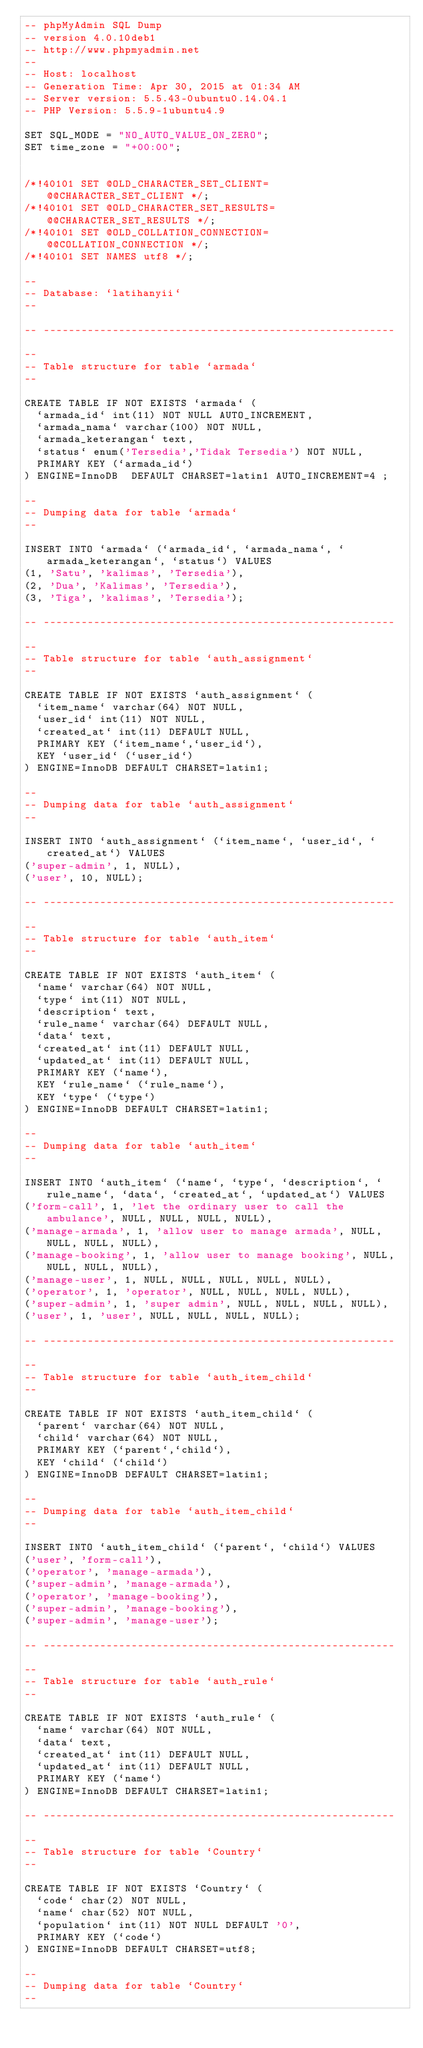<code> <loc_0><loc_0><loc_500><loc_500><_SQL_>-- phpMyAdmin SQL Dump
-- version 4.0.10deb1
-- http://www.phpmyadmin.net
--
-- Host: localhost
-- Generation Time: Apr 30, 2015 at 01:34 AM
-- Server version: 5.5.43-0ubuntu0.14.04.1
-- PHP Version: 5.5.9-1ubuntu4.9

SET SQL_MODE = "NO_AUTO_VALUE_ON_ZERO";
SET time_zone = "+00:00";


/*!40101 SET @OLD_CHARACTER_SET_CLIENT=@@CHARACTER_SET_CLIENT */;
/*!40101 SET @OLD_CHARACTER_SET_RESULTS=@@CHARACTER_SET_RESULTS */;
/*!40101 SET @OLD_COLLATION_CONNECTION=@@COLLATION_CONNECTION */;
/*!40101 SET NAMES utf8 */;

--
-- Database: `latihanyii`
--

-- --------------------------------------------------------

--
-- Table structure for table `armada`
--

CREATE TABLE IF NOT EXISTS `armada` (
  `armada_id` int(11) NOT NULL AUTO_INCREMENT,
  `armada_nama` varchar(100) NOT NULL,
  `armada_keterangan` text,
  `status` enum('Tersedia','Tidak Tersedia') NOT NULL,
  PRIMARY KEY (`armada_id`)
) ENGINE=InnoDB  DEFAULT CHARSET=latin1 AUTO_INCREMENT=4 ;

--
-- Dumping data for table `armada`
--

INSERT INTO `armada` (`armada_id`, `armada_nama`, `armada_keterangan`, `status`) VALUES
(1, 'Satu', 'kalimas', 'Tersedia'),
(2, 'Dua', 'Kalimas', 'Tersedia'),
(3, 'Tiga', 'kalimas', 'Tersedia');

-- --------------------------------------------------------

--
-- Table structure for table `auth_assignment`
--

CREATE TABLE IF NOT EXISTS `auth_assignment` (
  `item_name` varchar(64) NOT NULL,
  `user_id` int(11) NOT NULL,
  `created_at` int(11) DEFAULT NULL,
  PRIMARY KEY (`item_name`,`user_id`),
  KEY `user_id` (`user_id`)
) ENGINE=InnoDB DEFAULT CHARSET=latin1;

--
-- Dumping data for table `auth_assignment`
--

INSERT INTO `auth_assignment` (`item_name`, `user_id`, `created_at`) VALUES
('super-admin', 1, NULL),
('user', 10, NULL);

-- --------------------------------------------------------

--
-- Table structure for table `auth_item`
--

CREATE TABLE IF NOT EXISTS `auth_item` (
  `name` varchar(64) NOT NULL,
  `type` int(11) NOT NULL,
  `description` text,
  `rule_name` varchar(64) DEFAULT NULL,
  `data` text,
  `created_at` int(11) DEFAULT NULL,
  `updated_at` int(11) DEFAULT NULL,
  PRIMARY KEY (`name`),
  KEY `rule_name` (`rule_name`),
  KEY `type` (`type`)
) ENGINE=InnoDB DEFAULT CHARSET=latin1;

--
-- Dumping data for table `auth_item`
--

INSERT INTO `auth_item` (`name`, `type`, `description`, `rule_name`, `data`, `created_at`, `updated_at`) VALUES
('form-call', 1, 'let the ordinary user to call the ambulance', NULL, NULL, NULL, NULL),
('manage-armada', 1, 'allow user to manage armada', NULL, NULL, NULL, NULL),
('manage-booking', 1, 'allow user to manage booking', NULL, NULL, NULL, NULL),
('manage-user', 1, NULL, NULL, NULL, NULL, NULL),
('operator', 1, 'operator', NULL, NULL, NULL, NULL),
('super-admin', 1, 'super admin', NULL, NULL, NULL, NULL),
('user', 1, 'user', NULL, NULL, NULL, NULL);

-- --------------------------------------------------------

--
-- Table structure for table `auth_item_child`
--

CREATE TABLE IF NOT EXISTS `auth_item_child` (
  `parent` varchar(64) NOT NULL,
  `child` varchar(64) NOT NULL,
  PRIMARY KEY (`parent`,`child`),
  KEY `child` (`child`)
) ENGINE=InnoDB DEFAULT CHARSET=latin1;

--
-- Dumping data for table `auth_item_child`
--

INSERT INTO `auth_item_child` (`parent`, `child`) VALUES
('user', 'form-call'),
('operator', 'manage-armada'),
('super-admin', 'manage-armada'),
('operator', 'manage-booking'),
('super-admin', 'manage-booking'),
('super-admin', 'manage-user');

-- --------------------------------------------------------

--
-- Table structure for table `auth_rule`
--

CREATE TABLE IF NOT EXISTS `auth_rule` (
  `name` varchar(64) NOT NULL,
  `data` text,
  `created_at` int(11) DEFAULT NULL,
  `updated_at` int(11) DEFAULT NULL,
  PRIMARY KEY (`name`)
) ENGINE=InnoDB DEFAULT CHARSET=latin1;

-- --------------------------------------------------------

--
-- Table structure for table `Country`
--

CREATE TABLE IF NOT EXISTS `Country` (
  `code` char(2) NOT NULL,
  `name` char(52) NOT NULL,
  `population` int(11) NOT NULL DEFAULT '0',
  PRIMARY KEY (`code`)
) ENGINE=InnoDB DEFAULT CHARSET=utf8;

--
-- Dumping data for table `Country`
--
</code> 